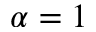Convert formula to latex. <formula><loc_0><loc_0><loc_500><loc_500>\alpha = 1</formula> 